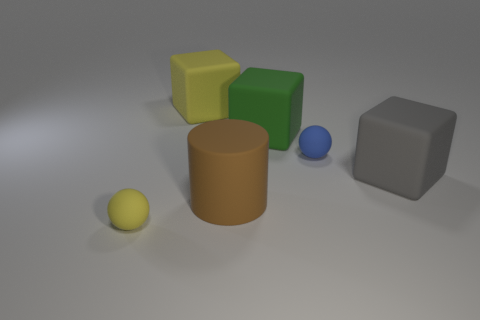Are there more large gray objects on the right side of the large gray rubber block than large objects?
Your answer should be very brief. No. Is there a sphere of the same color as the cylinder?
Give a very brief answer. No. The rubber cylinder that is the same size as the green rubber object is what color?
Offer a terse response. Brown. Is there a large gray cube that is in front of the small ball in front of the large gray rubber thing?
Your answer should be compact. No. There is a tiny thing behind the large matte cylinder; what material is it?
Offer a very short reply. Rubber. Does the ball to the left of the large yellow cube have the same material as the tiny thing that is behind the brown matte cylinder?
Offer a very short reply. Yes. Is the number of small rubber spheres right of the yellow rubber sphere the same as the number of rubber cylinders that are to the right of the big brown matte object?
Offer a very short reply. No. How many large green things are the same material as the tiny yellow thing?
Provide a short and direct response. 1. There is a yellow matte thing that is behind the big matte cube that is right of the large green object; what is its size?
Provide a succinct answer. Large. Is the shape of the yellow thing left of the big yellow matte thing the same as the small rubber thing that is right of the large brown thing?
Your answer should be compact. Yes. 